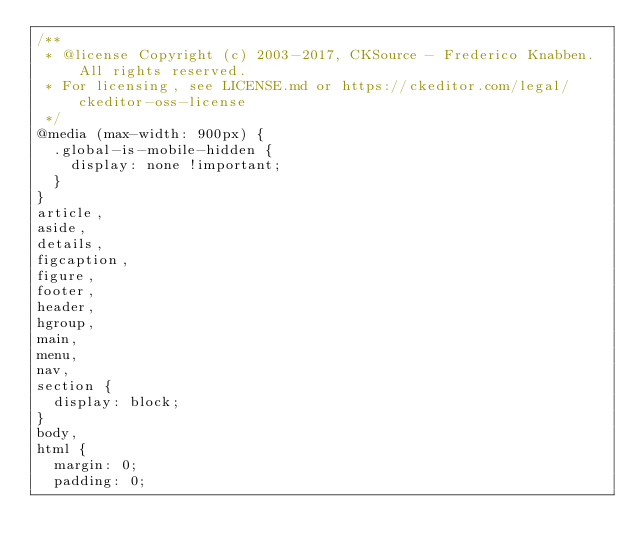<code> <loc_0><loc_0><loc_500><loc_500><_CSS_>/**
 * @license Copyright (c) 2003-2017, CKSource - Frederico Knabben. All rights reserved.
 * For licensing, see LICENSE.md or https://ckeditor.com/legal/ckeditor-oss-license
 */
@media (max-width: 900px) {
  .global-is-mobile-hidden {
    display: none !important;
  }
}
article,
aside,
details,
figcaption,
figure,
footer,
header,
hgroup,
main,
menu,
nav,
section {
  display: block;
}
body,
html {
  margin: 0;
  padding: 0;</code> 